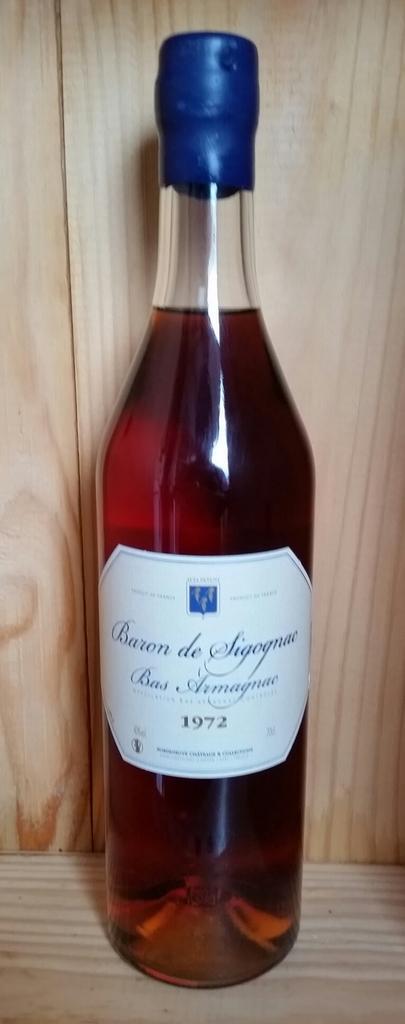Please provide a concise description of this image. In this image I see a bottle. 